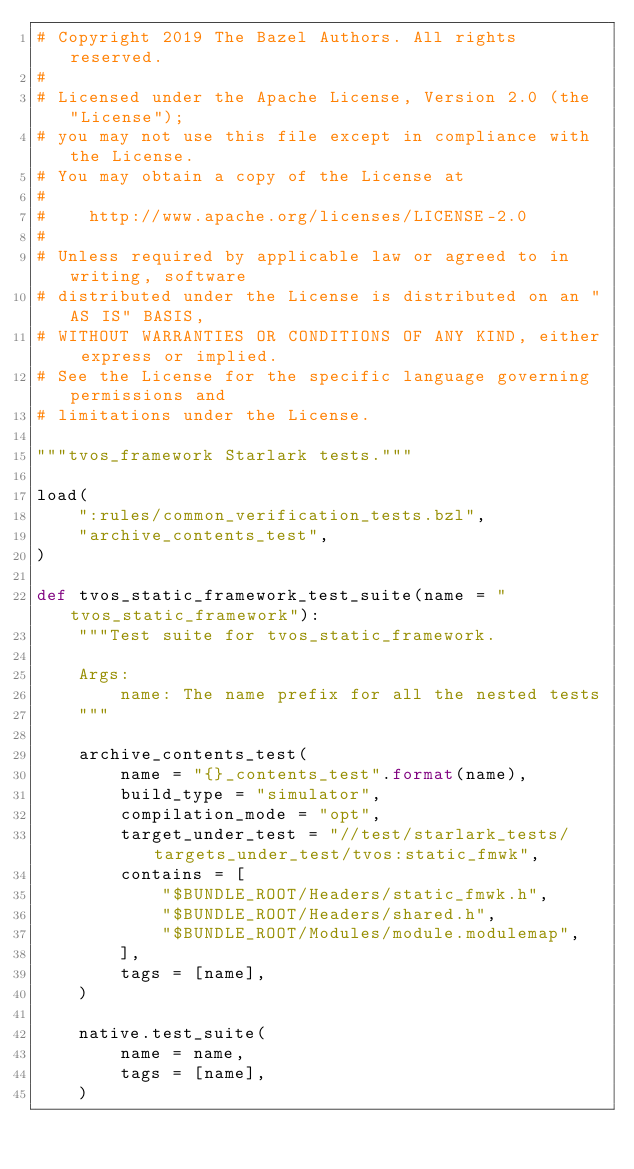Convert code to text. <code><loc_0><loc_0><loc_500><loc_500><_Python_># Copyright 2019 The Bazel Authors. All rights reserved.
#
# Licensed under the Apache License, Version 2.0 (the "License");
# you may not use this file except in compliance with the License.
# You may obtain a copy of the License at
#
#    http://www.apache.org/licenses/LICENSE-2.0
#
# Unless required by applicable law or agreed to in writing, software
# distributed under the License is distributed on an "AS IS" BASIS,
# WITHOUT WARRANTIES OR CONDITIONS OF ANY KIND, either express or implied.
# See the License for the specific language governing permissions and
# limitations under the License.

"""tvos_framework Starlark tests."""

load(
    ":rules/common_verification_tests.bzl",
    "archive_contents_test",
)

def tvos_static_framework_test_suite(name = "tvos_static_framework"):
    """Test suite for tvos_static_framework.

    Args:
        name: The name prefix for all the nested tests
    """

    archive_contents_test(
        name = "{}_contents_test".format(name),
        build_type = "simulator",
        compilation_mode = "opt",
        target_under_test = "//test/starlark_tests/targets_under_test/tvos:static_fmwk",
        contains = [
            "$BUNDLE_ROOT/Headers/static_fmwk.h",
            "$BUNDLE_ROOT/Headers/shared.h",
            "$BUNDLE_ROOT/Modules/module.modulemap",
        ],
        tags = [name],
    )

    native.test_suite(
        name = name,
        tags = [name],
    )
</code> 